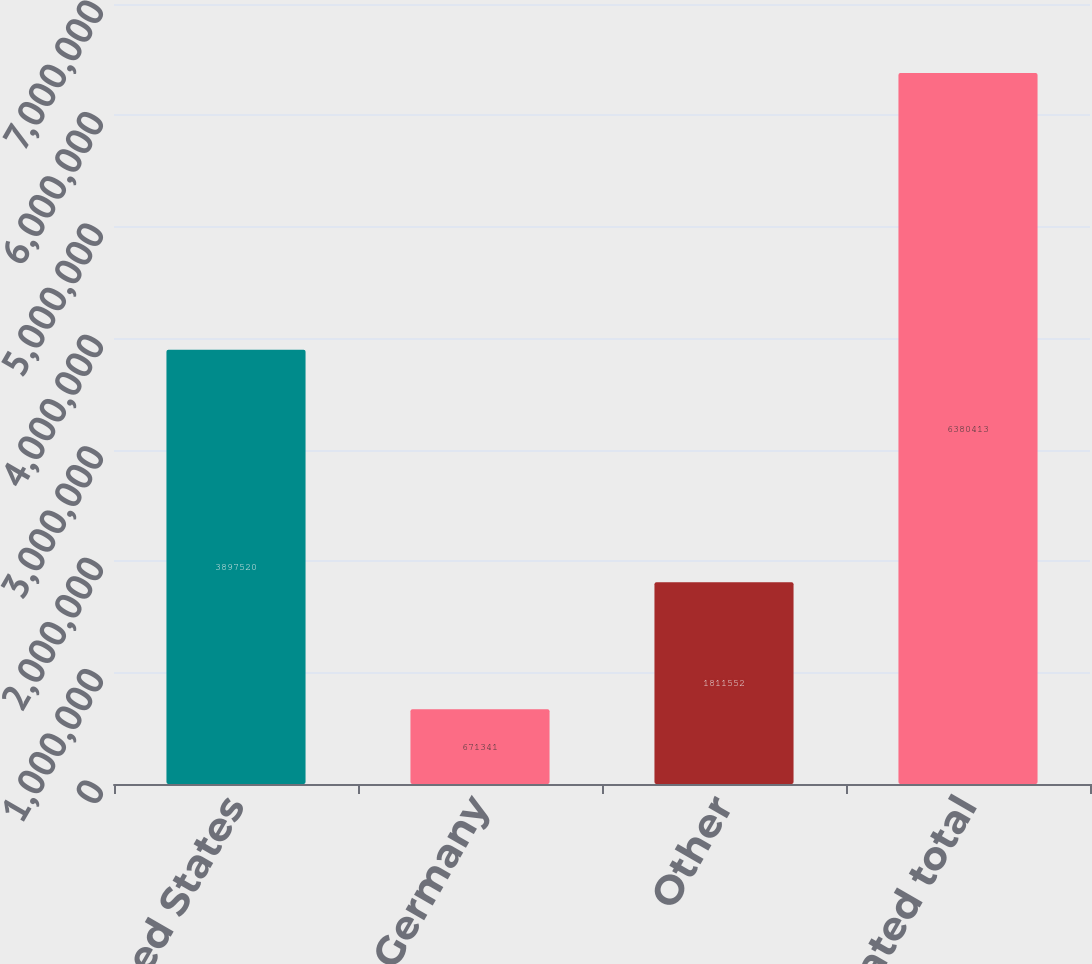Convert chart to OTSL. <chart><loc_0><loc_0><loc_500><loc_500><bar_chart><fcel>United States<fcel>Germany<fcel>Other<fcel>Consolidated total<nl><fcel>3.89752e+06<fcel>671341<fcel>1.81155e+06<fcel>6.38041e+06<nl></chart> 